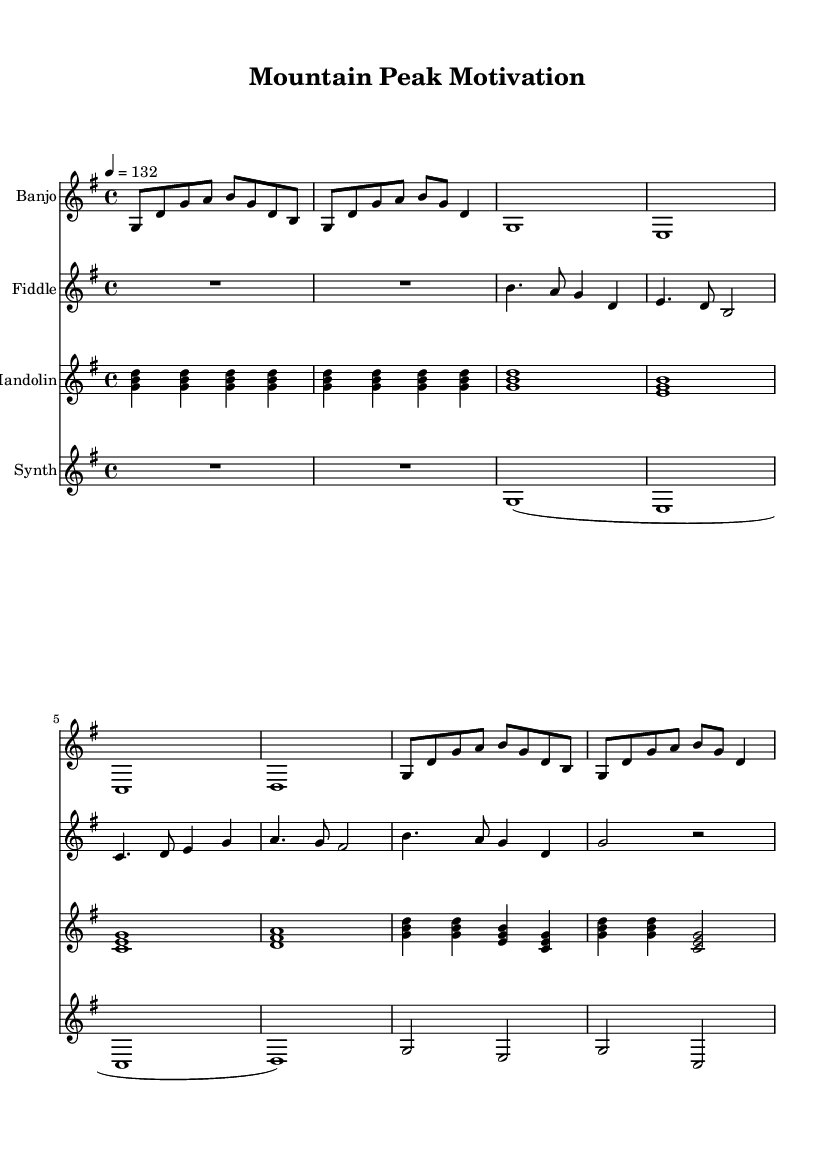What is the key signature of this music? The key signature is G major, which is indicated by one sharp (F#) in the key signature section of the staff.
Answer: G major What is the time signature of this music? The time signature is 4/4, shown at the beginning of the score, indicating four beats per measure, with the quarter note receiving one beat.
Answer: 4/4 What is the tempo of this piece? The tempo marking is given as 132 beats per minute, which is indicated near the beginning of the score, as "4 = 132."
Answer: 132 How many measures are there in the banjo part? By counting the distinct sections divided by bar lines, the banjo part has a total of eight measures.
Answer: 8 Which instrument plays the longest sustained note? The synth plays the longest sustained notes, as indicated by the whole notes in its part, specifically at the beginning where it holds notes for an entire measure.
Answer: Synth How many distinct sections are in the fiddle part? The fiddle part has six distinct sections, identifiable by the measures and rests throughout its notation, counting the bars of music.
Answer: 6 What is the highest pitch played in the mandolin part? The highest pitch in the mandolin part is the note "g", reached in the section where multiple pitches are played using simultaneous notes.
Answer: g 